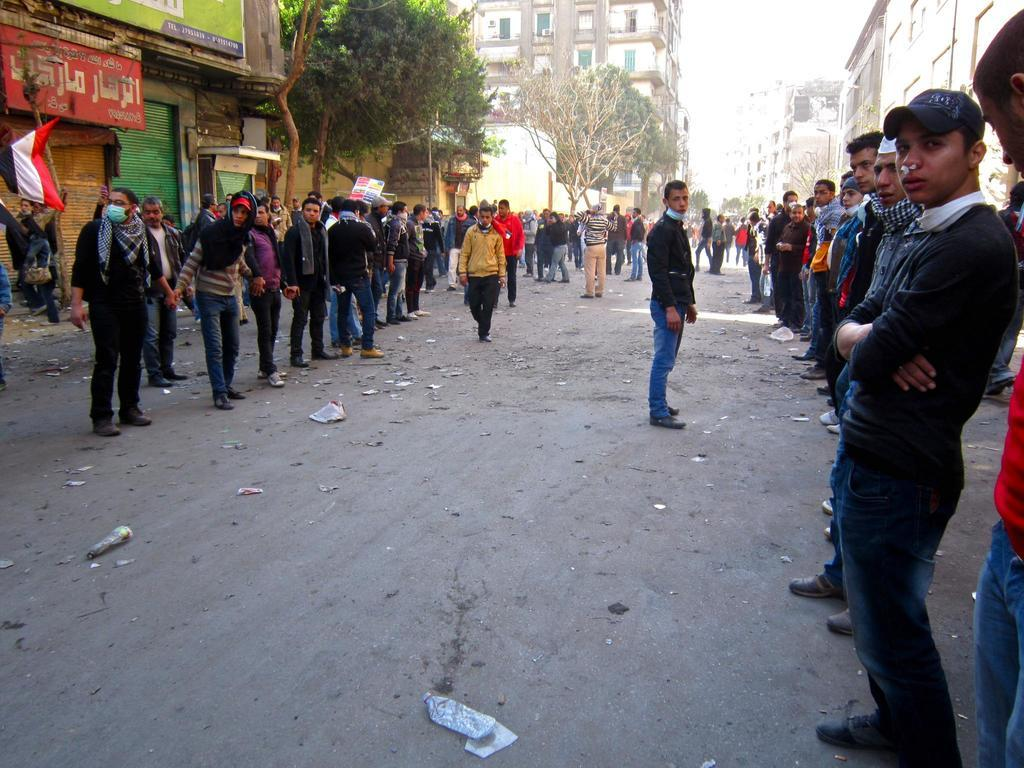What is happening on the road in the image? There is a crowd on the road in the image. What can be seen in the background of the image? There are trees and buildings in the background of the image. Where is the flag located in the image? The flag is on the left side of the image. How much profit did the babies make in the image? There are no babies present in the image, and therefore no profit can be attributed to them. 